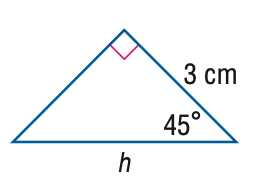Answer the mathemtical geometry problem and directly provide the correct option letter.
Question: Find h in the triangle.
Choices: A: 3 \sqrt 2 B: 3 \sqrt 3 C: 6 D: 6 \sqrt 2 A 